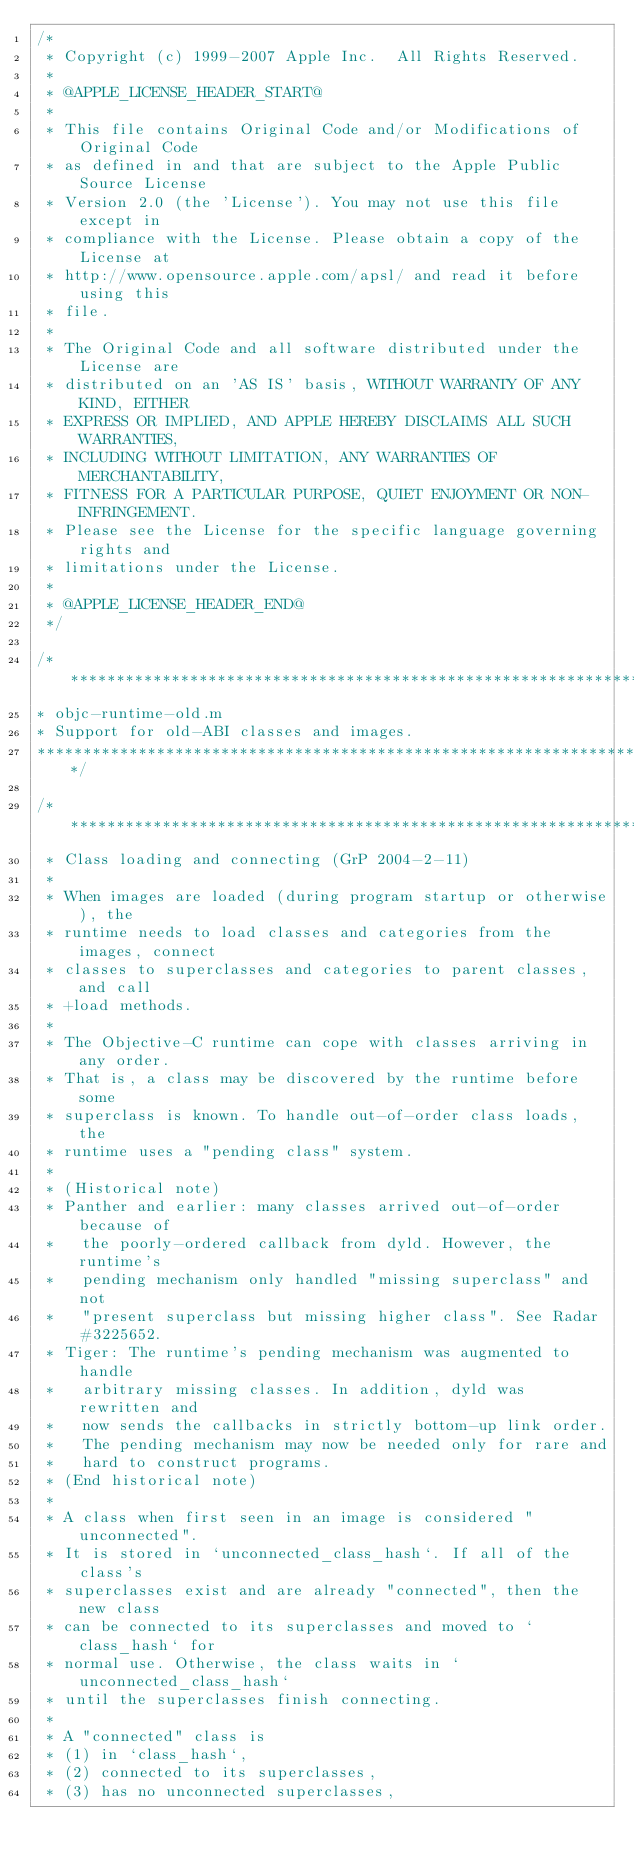Convert code to text. <code><loc_0><loc_0><loc_500><loc_500><_ObjectiveC_>/*
 * Copyright (c) 1999-2007 Apple Inc.  All Rights Reserved.
 * 
 * @APPLE_LICENSE_HEADER_START@
 * 
 * This file contains Original Code and/or Modifications of Original Code
 * as defined in and that are subject to the Apple Public Source License
 * Version 2.0 (the 'License'). You may not use this file except in
 * compliance with the License. Please obtain a copy of the License at
 * http://www.opensource.apple.com/apsl/ and read it before using this
 * file.
 * 
 * The Original Code and all software distributed under the License are
 * distributed on an 'AS IS' basis, WITHOUT WARRANTY OF ANY KIND, EITHER
 * EXPRESS OR IMPLIED, AND APPLE HEREBY DISCLAIMS ALL SUCH WARRANTIES,
 * INCLUDING WITHOUT LIMITATION, ANY WARRANTIES OF MERCHANTABILITY,
 * FITNESS FOR A PARTICULAR PURPOSE, QUIET ENJOYMENT OR NON-INFRINGEMENT.
 * Please see the License for the specific language governing rights and
 * limitations under the License.
 * 
 * @APPLE_LICENSE_HEADER_END@
 */

/***********************************************************************
* objc-runtime-old.m
* Support for old-ABI classes and images.
**********************************************************************/

/***********************************************************************
 * Class loading and connecting (GrP 2004-2-11)
 *
 * When images are loaded (during program startup or otherwise), the 
 * runtime needs to load classes and categories from the images, connect 
 * classes to superclasses and categories to parent classes, and call 
 * +load methods. 
 * 
 * The Objective-C runtime can cope with classes arriving in any order. 
 * That is, a class may be discovered by the runtime before some 
 * superclass is known. To handle out-of-order class loads, the 
 * runtime uses a "pending class" system. 
 * 
 * (Historical note)
 * Panther and earlier: many classes arrived out-of-order because of 
 *   the poorly-ordered callback from dyld. However, the runtime's 
 *   pending mechanism only handled "missing superclass" and not 
 *   "present superclass but missing higher class". See Radar #3225652. 
 * Tiger: The runtime's pending mechanism was augmented to handle 
 *   arbitrary missing classes. In addition, dyld was rewritten and 
 *   now sends the callbacks in strictly bottom-up link order. 
 *   The pending mechanism may now be needed only for rare and 
 *   hard to construct programs.
 * (End historical note)
 * 
 * A class when first seen in an image is considered "unconnected". 
 * It is stored in `unconnected_class_hash`. If all of the class's 
 * superclasses exist and are already "connected", then the new class 
 * can be connected to its superclasses and moved to `class_hash` for 
 * normal use. Otherwise, the class waits in `unconnected_class_hash` 
 * until the superclasses finish connecting.
 * 
 * A "connected" class is 
 * (1) in `class_hash`, 
 * (2) connected to its superclasses, 
 * (3) has no unconnected superclasses, </code> 